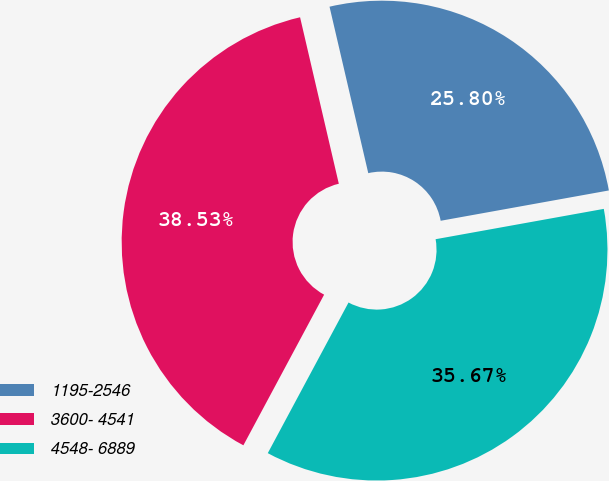Convert chart. <chart><loc_0><loc_0><loc_500><loc_500><pie_chart><fcel>1195-2546<fcel>3600- 4541<fcel>4548- 6889<nl><fcel>25.8%<fcel>38.53%<fcel>35.67%<nl></chart> 